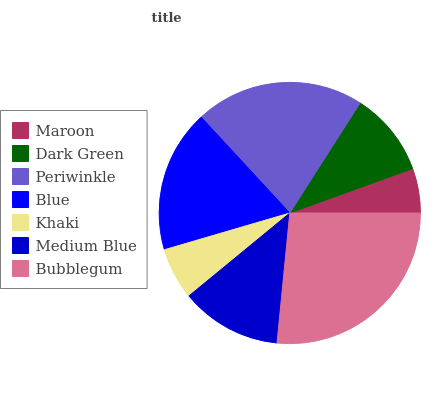Is Maroon the minimum?
Answer yes or no. Yes. Is Bubblegum the maximum?
Answer yes or no. Yes. Is Dark Green the minimum?
Answer yes or no. No. Is Dark Green the maximum?
Answer yes or no. No. Is Dark Green greater than Maroon?
Answer yes or no. Yes. Is Maroon less than Dark Green?
Answer yes or no. Yes. Is Maroon greater than Dark Green?
Answer yes or no. No. Is Dark Green less than Maroon?
Answer yes or no. No. Is Medium Blue the high median?
Answer yes or no. Yes. Is Medium Blue the low median?
Answer yes or no. Yes. Is Blue the high median?
Answer yes or no. No. Is Bubblegum the low median?
Answer yes or no. No. 